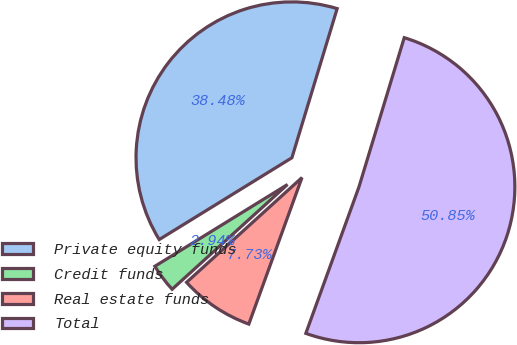Convert chart to OTSL. <chart><loc_0><loc_0><loc_500><loc_500><pie_chart><fcel>Private equity funds<fcel>Credit funds<fcel>Real estate funds<fcel>Total<nl><fcel>38.48%<fcel>2.94%<fcel>7.73%<fcel>50.85%<nl></chart> 